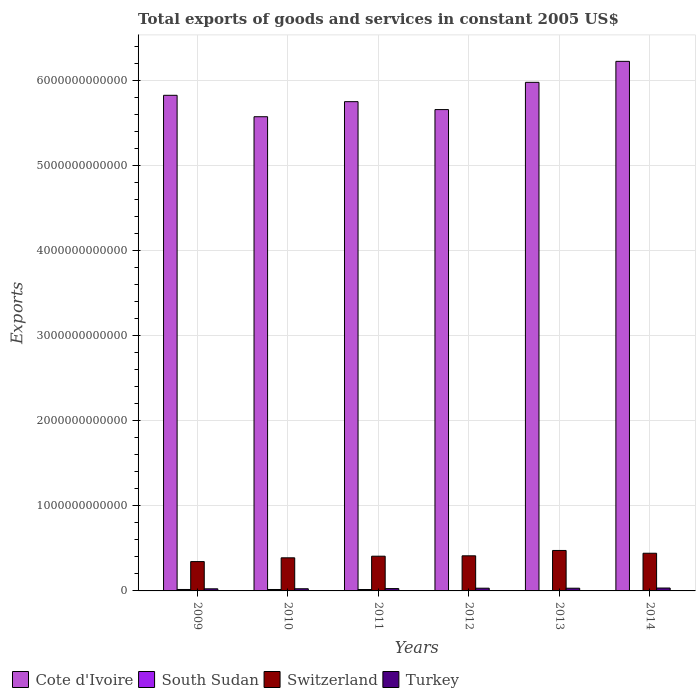How many groups of bars are there?
Offer a very short reply. 6. Are the number of bars per tick equal to the number of legend labels?
Ensure brevity in your answer.  Yes. How many bars are there on the 5th tick from the left?
Your answer should be very brief. 4. How many bars are there on the 2nd tick from the right?
Ensure brevity in your answer.  4. What is the label of the 1st group of bars from the left?
Provide a short and direct response. 2009. What is the total exports of goods and services in Cote d'Ivoire in 2009?
Provide a short and direct response. 5.83e+12. Across all years, what is the maximum total exports of goods and services in South Sudan?
Provide a succinct answer. 1.70e+1. Across all years, what is the minimum total exports of goods and services in Switzerland?
Your response must be concise. 3.45e+11. In which year was the total exports of goods and services in Turkey minimum?
Make the answer very short. 2009. What is the total total exports of goods and services in Switzerland in the graph?
Make the answer very short. 2.48e+12. What is the difference between the total exports of goods and services in Switzerland in 2009 and that in 2012?
Your answer should be compact. -6.78e+1. What is the difference between the total exports of goods and services in Cote d'Ivoire in 2010 and the total exports of goods and services in South Sudan in 2014?
Make the answer very short. 5.57e+12. What is the average total exports of goods and services in Cote d'Ivoire per year?
Ensure brevity in your answer.  5.84e+12. In the year 2012, what is the difference between the total exports of goods and services in Switzerland and total exports of goods and services in South Sudan?
Your response must be concise. 4.12e+11. In how many years, is the total exports of goods and services in South Sudan greater than 1200000000000 US$?
Provide a succinct answer. 0. What is the ratio of the total exports of goods and services in Switzerland in 2011 to that in 2013?
Your answer should be compact. 0.86. Is the total exports of goods and services in Switzerland in 2011 less than that in 2012?
Make the answer very short. Yes. Is the difference between the total exports of goods and services in Switzerland in 2010 and 2012 greater than the difference between the total exports of goods and services in South Sudan in 2010 and 2012?
Your response must be concise. No. What is the difference between the highest and the second highest total exports of goods and services in Turkey?
Offer a very short reply. 2.11e+09. What is the difference between the highest and the lowest total exports of goods and services in Cote d'Ivoire?
Provide a short and direct response. 6.51e+11. In how many years, is the total exports of goods and services in Switzerland greater than the average total exports of goods and services in Switzerland taken over all years?
Give a very brief answer. 3. Is the sum of the total exports of goods and services in Turkey in 2011 and 2014 greater than the maximum total exports of goods and services in Cote d'Ivoire across all years?
Provide a succinct answer. No. Is it the case that in every year, the sum of the total exports of goods and services in Turkey and total exports of goods and services in Cote d'Ivoire is greater than the sum of total exports of goods and services in South Sudan and total exports of goods and services in Switzerland?
Provide a succinct answer. Yes. What does the 4th bar from the left in 2014 represents?
Ensure brevity in your answer.  Turkey. What does the 3rd bar from the right in 2010 represents?
Provide a succinct answer. South Sudan. Are all the bars in the graph horizontal?
Make the answer very short. No. What is the difference between two consecutive major ticks on the Y-axis?
Provide a short and direct response. 1.00e+12. Are the values on the major ticks of Y-axis written in scientific E-notation?
Give a very brief answer. No. Does the graph contain any zero values?
Keep it short and to the point. No. How are the legend labels stacked?
Ensure brevity in your answer.  Horizontal. What is the title of the graph?
Offer a terse response. Total exports of goods and services in constant 2005 US$. What is the label or title of the Y-axis?
Offer a terse response. Exports. What is the Exports of Cote d'Ivoire in 2009?
Make the answer very short. 5.83e+12. What is the Exports of South Sudan in 2009?
Your response must be concise. 1.70e+1. What is the Exports of Switzerland in 2009?
Offer a very short reply. 3.45e+11. What is the Exports in Turkey in 2009?
Your answer should be very brief. 2.47e+1. What is the Exports in Cote d'Ivoire in 2010?
Offer a very short reply. 5.58e+12. What is the Exports of South Sudan in 2010?
Provide a short and direct response. 1.68e+1. What is the Exports of Switzerland in 2010?
Keep it short and to the point. 3.89e+11. What is the Exports in Turkey in 2010?
Provide a succinct answer. 2.55e+1. What is the Exports in Cote d'Ivoire in 2011?
Give a very brief answer. 5.76e+12. What is the Exports in South Sudan in 2011?
Ensure brevity in your answer.  1.64e+1. What is the Exports in Switzerland in 2011?
Your answer should be very brief. 4.09e+11. What is the Exports in Turkey in 2011?
Your response must be concise. 2.75e+1. What is the Exports of Cote d'Ivoire in 2012?
Make the answer very short. 5.66e+12. What is the Exports of South Sudan in 2012?
Your answer should be very brief. 1.33e+09. What is the Exports of Switzerland in 2012?
Provide a succinct answer. 4.13e+11. What is the Exports in Turkey in 2012?
Make the answer very short. 3.20e+1. What is the Exports in Cote d'Ivoire in 2013?
Offer a very short reply. 5.98e+12. What is the Exports in South Sudan in 2013?
Offer a very short reply. 2.66e+09. What is the Exports of Switzerland in 2013?
Keep it short and to the point. 4.76e+11. What is the Exports of Turkey in 2013?
Make the answer very short. 3.19e+1. What is the Exports of Cote d'Ivoire in 2014?
Your answer should be compact. 6.23e+12. What is the Exports in South Sudan in 2014?
Make the answer very short. 4.06e+09. What is the Exports of Switzerland in 2014?
Provide a succinct answer. 4.43e+11. What is the Exports in Turkey in 2014?
Make the answer very short. 3.41e+1. Across all years, what is the maximum Exports of Cote d'Ivoire?
Provide a short and direct response. 6.23e+12. Across all years, what is the maximum Exports in South Sudan?
Give a very brief answer. 1.70e+1. Across all years, what is the maximum Exports in Switzerland?
Make the answer very short. 4.76e+11. Across all years, what is the maximum Exports in Turkey?
Make the answer very short. 3.41e+1. Across all years, what is the minimum Exports of Cote d'Ivoire?
Your response must be concise. 5.58e+12. Across all years, what is the minimum Exports in South Sudan?
Provide a succinct answer. 1.33e+09. Across all years, what is the minimum Exports of Switzerland?
Offer a terse response. 3.45e+11. Across all years, what is the minimum Exports in Turkey?
Provide a short and direct response. 2.47e+1. What is the total Exports in Cote d'Ivoire in the graph?
Keep it short and to the point. 3.50e+13. What is the total Exports of South Sudan in the graph?
Your answer should be very brief. 5.83e+1. What is the total Exports in Switzerland in the graph?
Offer a terse response. 2.48e+12. What is the total Exports of Turkey in the graph?
Your answer should be very brief. 1.76e+11. What is the difference between the Exports of Cote d'Ivoire in 2009 and that in 2010?
Your answer should be compact. 2.52e+11. What is the difference between the Exports in South Sudan in 2009 and that in 2010?
Make the answer very short. 2.67e+08. What is the difference between the Exports of Switzerland in 2009 and that in 2010?
Your response must be concise. -4.43e+1. What is the difference between the Exports of Turkey in 2009 and that in 2010?
Your answer should be very brief. -8.40e+08. What is the difference between the Exports of Cote d'Ivoire in 2009 and that in 2011?
Provide a succinct answer. 7.47e+1. What is the difference between the Exports in South Sudan in 2009 and that in 2011?
Offer a terse response. 6.14e+08. What is the difference between the Exports of Switzerland in 2009 and that in 2011?
Your answer should be very brief. -6.34e+1. What is the difference between the Exports in Turkey in 2009 and that in 2011?
Make the answer very short. -2.85e+09. What is the difference between the Exports in Cote d'Ivoire in 2009 and that in 2012?
Ensure brevity in your answer.  1.68e+11. What is the difference between the Exports of South Sudan in 2009 and that in 2012?
Keep it short and to the point. 1.57e+1. What is the difference between the Exports of Switzerland in 2009 and that in 2012?
Provide a succinct answer. -6.78e+1. What is the difference between the Exports in Turkey in 2009 and that in 2012?
Provide a succinct answer. -7.34e+09. What is the difference between the Exports in Cote d'Ivoire in 2009 and that in 2013?
Your answer should be very brief. -1.53e+11. What is the difference between the Exports of South Sudan in 2009 and that in 2013?
Keep it short and to the point. 1.44e+1. What is the difference between the Exports in Switzerland in 2009 and that in 2013?
Your response must be concise. -1.31e+11. What is the difference between the Exports in Turkey in 2009 and that in 2013?
Make the answer very short. -7.27e+09. What is the difference between the Exports in Cote d'Ivoire in 2009 and that in 2014?
Offer a terse response. -3.99e+11. What is the difference between the Exports in South Sudan in 2009 and that in 2014?
Give a very brief answer. 1.30e+1. What is the difference between the Exports in Switzerland in 2009 and that in 2014?
Offer a terse response. -9.80e+1. What is the difference between the Exports of Turkey in 2009 and that in 2014?
Keep it short and to the point. -9.45e+09. What is the difference between the Exports of Cote d'Ivoire in 2010 and that in 2011?
Offer a very short reply. -1.77e+11. What is the difference between the Exports in South Sudan in 2010 and that in 2011?
Make the answer very short. 3.47e+08. What is the difference between the Exports in Switzerland in 2010 and that in 2011?
Your answer should be compact. -1.91e+1. What is the difference between the Exports of Turkey in 2010 and that in 2011?
Ensure brevity in your answer.  -2.01e+09. What is the difference between the Exports in Cote d'Ivoire in 2010 and that in 2012?
Provide a succinct answer. -8.40e+1. What is the difference between the Exports of South Sudan in 2010 and that in 2012?
Keep it short and to the point. 1.54e+1. What is the difference between the Exports in Switzerland in 2010 and that in 2012?
Your answer should be very brief. -2.35e+1. What is the difference between the Exports of Turkey in 2010 and that in 2012?
Keep it short and to the point. -6.50e+09. What is the difference between the Exports of Cote d'Ivoire in 2010 and that in 2013?
Provide a short and direct response. -4.04e+11. What is the difference between the Exports in South Sudan in 2010 and that in 2013?
Offer a very short reply. 1.41e+1. What is the difference between the Exports in Switzerland in 2010 and that in 2013?
Offer a terse response. -8.64e+1. What is the difference between the Exports of Turkey in 2010 and that in 2013?
Keep it short and to the point. -6.43e+09. What is the difference between the Exports of Cote d'Ivoire in 2010 and that in 2014?
Ensure brevity in your answer.  -6.51e+11. What is the difference between the Exports of South Sudan in 2010 and that in 2014?
Offer a terse response. 1.27e+1. What is the difference between the Exports in Switzerland in 2010 and that in 2014?
Offer a terse response. -5.37e+1. What is the difference between the Exports of Turkey in 2010 and that in 2014?
Your answer should be compact. -8.61e+09. What is the difference between the Exports of Cote d'Ivoire in 2011 and that in 2012?
Offer a terse response. 9.32e+1. What is the difference between the Exports of South Sudan in 2011 and that in 2012?
Make the answer very short. 1.51e+1. What is the difference between the Exports of Switzerland in 2011 and that in 2012?
Offer a terse response. -4.38e+09. What is the difference between the Exports in Turkey in 2011 and that in 2012?
Keep it short and to the point. -4.49e+09. What is the difference between the Exports of Cote d'Ivoire in 2011 and that in 2013?
Make the answer very short. -2.27e+11. What is the difference between the Exports in South Sudan in 2011 and that in 2013?
Provide a succinct answer. 1.38e+1. What is the difference between the Exports of Switzerland in 2011 and that in 2013?
Your answer should be very brief. -6.73e+1. What is the difference between the Exports in Turkey in 2011 and that in 2013?
Keep it short and to the point. -4.42e+09. What is the difference between the Exports of Cote d'Ivoire in 2011 and that in 2014?
Provide a succinct answer. -4.74e+11. What is the difference between the Exports of South Sudan in 2011 and that in 2014?
Give a very brief answer. 1.24e+1. What is the difference between the Exports in Switzerland in 2011 and that in 2014?
Provide a succinct answer. -3.46e+1. What is the difference between the Exports of Turkey in 2011 and that in 2014?
Your answer should be very brief. -6.60e+09. What is the difference between the Exports in Cote d'Ivoire in 2012 and that in 2013?
Keep it short and to the point. -3.20e+11. What is the difference between the Exports of South Sudan in 2012 and that in 2013?
Provide a short and direct response. -1.33e+09. What is the difference between the Exports in Switzerland in 2012 and that in 2013?
Make the answer very short. -6.29e+1. What is the difference between the Exports in Turkey in 2012 and that in 2013?
Your response must be concise. 6.73e+07. What is the difference between the Exports in Cote d'Ivoire in 2012 and that in 2014?
Ensure brevity in your answer.  -5.67e+11. What is the difference between the Exports in South Sudan in 2012 and that in 2014?
Your answer should be very brief. -2.73e+09. What is the difference between the Exports in Switzerland in 2012 and that in 2014?
Your response must be concise. -3.02e+1. What is the difference between the Exports in Turkey in 2012 and that in 2014?
Provide a short and direct response. -2.11e+09. What is the difference between the Exports of Cote d'Ivoire in 2013 and that in 2014?
Provide a short and direct response. -2.47e+11. What is the difference between the Exports of South Sudan in 2013 and that in 2014?
Offer a very short reply. -1.40e+09. What is the difference between the Exports of Switzerland in 2013 and that in 2014?
Your answer should be very brief. 3.27e+1. What is the difference between the Exports in Turkey in 2013 and that in 2014?
Provide a succinct answer. -2.18e+09. What is the difference between the Exports in Cote d'Ivoire in 2009 and the Exports in South Sudan in 2010?
Make the answer very short. 5.81e+12. What is the difference between the Exports of Cote d'Ivoire in 2009 and the Exports of Switzerland in 2010?
Provide a succinct answer. 5.44e+12. What is the difference between the Exports in Cote d'Ivoire in 2009 and the Exports in Turkey in 2010?
Your response must be concise. 5.80e+12. What is the difference between the Exports in South Sudan in 2009 and the Exports in Switzerland in 2010?
Make the answer very short. -3.72e+11. What is the difference between the Exports in South Sudan in 2009 and the Exports in Turkey in 2010?
Your answer should be very brief. -8.46e+09. What is the difference between the Exports of Switzerland in 2009 and the Exports of Turkey in 2010?
Ensure brevity in your answer.  3.20e+11. What is the difference between the Exports of Cote d'Ivoire in 2009 and the Exports of South Sudan in 2011?
Give a very brief answer. 5.81e+12. What is the difference between the Exports in Cote d'Ivoire in 2009 and the Exports in Switzerland in 2011?
Keep it short and to the point. 5.42e+12. What is the difference between the Exports in Cote d'Ivoire in 2009 and the Exports in Turkey in 2011?
Give a very brief answer. 5.80e+12. What is the difference between the Exports of South Sudan in 2009 and the Exports of Switzerland in 2011?
Provide a short and direct response. -3.92e+11. What is the difference between the Exports in South Sudan in 2009 and the Exports in Turkey in 2011?
Offer a very short reply. -1.05e+1. What is the difference between the Exports of Switzerland in 2009 and the Exports of Turkey in 2011?
Your answer should be compact. 3.18e+11. What is the difference between the Exports in Cote d'Ivoire in 2009 and the Exports in South Sudan in 2012?
Your answer should be compact. 5.83e+12. What is the difference between the Exports in Cote d'Ivoire in 2009 and the Exports in Switzerland in 2012?
Give a very brief answer. 5.42e+12. What is the difference between the Exports in Cote d'Ivoire in 2009 and the Exports in Turkey in 2012?
Make the answer very short. 5.80e+12. What is the difference between the Exports of South Sudan in 2009 and the Exports of Switzerland in 2012?
Provide a succinct answer. -3.96e+11. What is the difference between the Exports of South Sudan in 2009 and the Exports of Turkey in 2012?
Your answer should be compact. -1.50e+1. What is the difference between the Exports of Switzerland in 2009 and the Exports of Turkey in 2012?
Provide a short and direct response. 3.13e+11. What is the difference between the Exports of Cote d'Ivoire in 2009 and the Exports of South Sudan in 2013?
Provide a succinct answer. 5.83e+12. What is the difference between the Exports in Cote d'Ivoire in 2009 and the Exports in Switzerland in 2013?
Make the answer very short. 5.35e+12. What is the difference between the Exports of Cote d'Ivoire in 2009 and the Exports of Turkey in 2013?
Keep it short and to the point. 5.80e+12. What is the difference between the Exports of South Sudan in 2009 and the Exports of Switzerland in 2013?
Your response must be concise. -4.59e+11. What is the difference between the Exports in South Sudan in 2009 and the Exports in Turkey in 2013?
Ensure brevity in your answer.  -1.49e+1. What is the difference between the Exports in Switzerland in 2009 and the Exports in Turkey in 2013?
Make the answer very short. 3.13e+11. What is the difference between the Exports of Cote d'Ivoire in 2009 and the Exports of South Sudan in 2014?
Make the answer very short. 5.83e+12. What is the difference between the Exports in Cote d'Ivoire in 2009 and the Exports in Switzerland in 2014?
Give a very brief answer. 5.39e+12. What is the difference between the Exports of Cote d'Ivoire in 2009 and the Exports of Turkey in 2014?
Offer a terse response. 5.80e+12. What is the difference between the Exports in South Sudan in 2009 and the Exports in Switzerland in 2014?
Provide a succinct answer. -4.26e+11. What is the difference between the Exports in South Sudan in 2009 and the Exports in Turkey in 2014?
Give a very brief answer. -1.71e+1. What is the difference between the Exports in Switzerland in 2009 and the Exports in Turkey in 2014?
Provide a succinct answer. 3.11e+11. What is the difference between the Exports in Cote d'Ivoire in 2010 and the Exports in South Sudan in 2011?
Your response must be concise. 5.56e+12. What is the difference between the Exports in Cote d'Ivoire in 2010 and the Exports in Switzerland in 2011?
Offer a terse response. 5.17e+12. What is the difference between the Exports of Cote d'Ivoire in 2010 and the Exports of Turkey in 2011?
Give a very brief answer. 5.55e+12. What is the difference between the Exports of South Sudan in 2010 and the Exports of Switzerland in 2011?
Provide a succinct answer. -3.92e+11. What is the difference between the Exports in South Sudan in 2010 and the Exports in Turkey in 2011?
Provide a short and direct response. -1.07e+1. What is the difference between the Exports of Switzerland in 2010 and the Exports of Turkey in 2011?
Provide a short and direct response. 3.62e+11. What is the difference between the Exports in Cote d'Ivoire in 2010 and the Exports in South Sudan in 2012?
Your answer should be compact. 5.58e+12. What is the difference between the Exports of Cote d'Ivoire in 2010 and the Exports of Switzerland in 2012?
Your answer should be compact. 5.16e+12. What is the difference between the Exports of Cote d'Ivoire in 2010 and the Exports of Turkey in 2012?
Provide a succinct answer. 5.55e+12. What is the difference between the Exports of South Sudan in 2010 and the Exports of Switzerland in 2012?
Make the answer very short. -3.96e+11. What is the difference between the Exports in South Sudan in 2010 and the Exports in Turkey in 2012?
Offer a very short reply. -1.52e+1. What is the difference between the Exports of Switzerland in 2010 and the Exports of Turkey in 2012?
Your answer should be compact. 3.57e+11. What is the difference between the Exports of Cote d'Ivoire in 2010 and the Exports of South Sudan in 2013?
Provide a succinct answer. 5.58e+12. What is the difference between the Exports in Cote d'Ivoire in 2010 and the Exports in Switzerland in 2013?
Offer a very short reply. 5.10e+12. What is the difference between the Exports in Cote d'Ivoire in 2010 and the Exports in Turkey in 2013?
Offer a very short reply. 5.55e+12. What is the difference between the Exports in South Sudan in 2010 and the Exports in Switzerland in 2013?
Offer a terse response. -4.59e+11. What is the difference between the Exports of South Sudan in 2010 and the Exports of Turkey in 2013?
Keep it short and to the point. -1.52e+1. What is the difference between the Exports of Switzerland in 2010 and the Exports of Turkey in 2013?
Your answer should be compact. 3.58e+11. What is the difference between the Exports in Cote d'Ivoire in 2010 and the Exports in South Sudan in 2014?
Offer a very short reply. 5.57e+12. What is the difference between the Exports of Cote d'Ivoire in 2010 and the Exports of Switzerland in 2014?
Provide a succinct answer. 5.13e+12. What is the difference between the Exports of Cote d'Ivoire in 2010 and the Exports of Turkey in 2014?
Provide a succinct answer. 5.54e+12. What is the difference between the Exports of South Sudan in 2010 and the Exports of Switzerland in 2014?
Offer a very short reply. -4.26e+11. What is the difference between the Exports in South Sudan in 2010 and the Exports in Turkey in 2014?
Offer a very short reply. -1.73e+1. What is the difference between the Exports in Switzerland in 2010 and the Exports in Turkey in 2014?
Your response must be concise. 3.55e+11. What is the difference between the Exports of Cote d'Ivoire in 2011 and the Exports of South Sudan in 2012?
Your answer should be very brief. 5.75e+12. What is the difference between the Exports of Cote d'Ivoire in 2011 and the Exports of Switzerland in 2012?
Provide a succinct answer. 5.34e+12. What is the difference between the Exports in Cote d'Ivoire in 2011 and the Exports in Turkey in 2012?
Provide a short and direct response. 5.72e+12. What is the difference between the Exports in South Sudan in 2011 and the Exports in Switzerland in 2012?
Your answer should be compact. -3.97e+11. What is the difference between the Exports of South Sudan in 2011 and the Exports of Turkey in 2012?
Your answer should be compact. -1.56e+1. What is the difference between the Exports in Switzerland in 2011 and the Exports in Turkey in 2012?
Offer a terse response. 3.77e+11. What is the difference between the Exports in Cote d'Ivoire in 2011 and the Exports in South Sudan in 2013?
Provide a succinct answer. 5.75e+12. What is the difference between the Exports of Cote d'Ivoire in 2011 and the Exports of Switzerland in 2013?
Your answer should be very brief. 5.28e+12. What is the difference between the Exports in Cote d'Ivoire in 2011 and the Exports in Turkey in 2013?
Offer a very short reply. 5.72e+12. What is the difference between the Exports of South Sudan in 2011 and the Exports of Switzerland in 2013?
Make the answer very short. -4.59e+11. What is the difference between the Exports of South Sudan in 2011 and the Exports of Turkey in 2013?
Offer a very short reply. -1.55e+1. What is the difference between the Exports of Switzerland in 2011 and the Exports of Turkey in 2013?
Your answer should be very brief. 3.77e+11. What is the difference between the Exports of Cote d'Ivoire in 2011 and the Exports of South Sudan in 2014?
Provide a succinct answer. 5.75e+12. What is the difference between the Exports of Cote d'Ivoire in 2011 and the Exports of Switzerland in 2014?
Provide a succinct answer. 5.31e+12. What is the difference between the Exports in Cote d'Ivoire in 2011 and the Exports in Turkey in 2014?
Provide a succinct answer. 5.72e+12. What is the difference between the Exports of South Sudan in 2011 and the Exports of Switzerland in 2014?
Keep it short and to the point. -4.27e+11. What is the difference between the Exports in South Sudan in 2011 and the Exports in Turkey in 2014?
Your response must be concise. -1.77e+1. What is the difference between the Exports in Switzerland in 2011 and the Exports in Turkey in 2014?
Offer a very short reply. 3.74e+11. What is the difference between the Exports in Cote d'Ivoire in 2012 and the Exports in South Sudan in 2013?
Your answer should be compact. 5.66e+12. What is the difference between the Exports of Cote d'Ivoire in 2012 and the Exports of Switzerland in 2013?
Offer a terse response. 5.19e+12. What is the difference between the Exports in Cote d'Ivoire in 2012 and the Exports in Turkey in 2013?
Provide a short and direct response. 5.63e+12. What is the difference between the Exports of South Sudan in 2012 and the Exports of Switzerland in 2013?
Your answer should be compact. -4.75e+11. What is the difference between the Exports in South Sudan in 2012 and the Exports in Turkey in 2013?
Keep it short and to the point. -3.06e+1. What is the difference between the Exports of Switzerland in 2012 and the Exports of Turkey in 2013?
Provide a short and direct response. 3.81e+11. What is the difference between the Exports of Cote d'Ivoire in 2012 and the Exports of South Sudan in 2014?
Your answer should be very brief. 5.66e+12. What is the difference between the Exports in Cote d'Ivoire in 2012 and the Exports in Switzerland in 2014?
Offer a terse response. 5.22e+12. What is the difference between the Exports in Cote d'Ivoire in 2012 and the Exports in Turkey in 2014?
Make the answer very short. 5.63e+12. What is the difference between the Exports in South Sudan in 2012 and the Exports in Switzerland in 2014?
Keep it short and to the point. -4.42e+11. What is the difference between the Exports in South Sudan in 2012 and the Exports in Turkey in 2014?
Provide a succinct answer. -3.28e+1. What is the difference between the Exports of Switzerland in 2012 and the Exports of Turkey in 2014?
Your response must be concise. 3.79e+11. What is the difference between the Exports of Cote d'Ivoire in 2013 and the Exports of South Sudan in 2014?
Your answer should be compact. 5.98e+12. What is the difference between the Exports of Cote d'Ivoire in 2013 and the Exports of Switzerland in 2014?
Offer a terse response. 5.54e+12. What is the difference between the Exports of Cote d'Ivoire in 2013 and the Exports of Turkey in 2014?
Keep it short and to the point. 5.95e+12. What is the difference between the Exports of South Sudan in 2013 and the Exports of Switzerland in 2014?
Offer a terse response. -4.40e+11. What is the difference between the Exports in South Sudan in 2013 and the Exports in Turkey in 2014?
Your answer should be very brief. -3.15e+1. What is the difference between the Exports of Switzerland in 2013 and the Exports of Turkey in 2014?
Make the answer very short. 4.42e+11. What is the average Exports in Cote d'Ivoire per year?
Ensure brevity in your answer.  5.84e+12. What is the average Exports in South Sudan per year?
Offer a very short reply. 9.72e+09. What is the average Exports of Switzerland per year?
Give a very brief answer. 4.13e+11. What is the average Exports in Turkey per year?
Give a very brief answer. 2.93e+1. In the year 2009, what is the difference between the Exports of Cote d'Ivoire and Exports of South Sudan?
Make the answer very short. 5.81e+12. In the year 2009, what is the difference between the Exports in Cote d'Ivoire and Exports in Switzerland?
Give a very brief answer. 5.48e+12. In the year 2009, what is the difference between the Exports in Cote d'Ivoire and Exports in Turkey?
Ensure brevity in your answer.  5.81e+12. In the year 2009, what is the difference between the Exports in South Sudan and Exports in Switzerland?
Your answer should be compact. -3.28e+11. In the year 2009, what is the difference between the Exports of South Sudan and Exports of Turkey?
Ensure brevity in your answer.  -7.62e+09. In the year 2009, what is the difference between the Exports of Switzerland and Exports of Turkey?
Give a very brief answer. 3.20e+11. In the year 2010, what is the difference between the Exports of Cote d'Ivoire and Exports of South Sudan?
Make the answer very short. 5.56e+12. In the year 2010, what is the difference between the Exports in Cote d'Ivoire and Exports in Switzerland?
Your answer should be compact. 5.19e+12. In the year 2010, what is the difference between the Exports in Cote d'Ivoire and Exports in Turkey?
Your response must be concise. 5.55e+12. In the year 2010, what is the difference between the Exports in South Sudan and Exports in Switzerland?
Offer a terse response. -3.73e+11. In the year 2010, what is the difference between the Exports of South Sudan and Exports of Turkey?
Provide a succinct answer. -8.73e+09. In the year 2010, what is the difference between the Exports in Switzerland and Exports in Turkey?
Make the answer very short. 3.64e+11. In the year 2011, what is the difference between the Exports of Cote d'Ivoire and Exports of South Sudan?
Your answer should be compact. 5.74e+12. In the year 2011, what is the difference between the Exports in Cote d'Ivoire and Exports in Switzerland?
Make the answer very short. 5.35e+12. In the year 2011, what is the difference between the Exports of Cote d'Ivoire and Exports of Turkey?
Your answer should be compact. 5.73e+12. In the year 2011, what is the difference between the Exports of South Sudan and Exports of Switzerland?
Your response must be concise. -3.92e+11. In the year 2011, what is the difference between the Exports in South Sudan and Exports in Turkey?
Provide a succinct answer. -1.11e+1. In the year 2011, what is the difference between the Exports of Switzerland and Exports of Turkey?
Your answer should be very brief. 3.81e+11. In the year 2012, what is the difference between the Exports of Cote d'Ivoire and Exports of South Sudan?
Give a very brief answer. 5.66e+12. In the year 2012, what is the difference between the Exports of Cote d'Ivoire and Exports of Switzerland?
Ensure brevity in your answer.  5.25e+12. In the year 2012, what is the difference between the Exports in Cote d'Ivoire and Exports in Turkey?
Offer a very short reply. 5.63e+12. In the year 2012, what is the difference between the Exports of South Sudan and Exports of Switzerland?
Give a very brief answer. -4.12e+11. In the year 2012, what is the difference between the Exports in South Sudan and Exports in Turkey?
Offer a terse response. -3.07e+1. In the year 2012, what is the difference between the Exports in Switzerland and Exports in Turkey?
Offer a terse response. 3.81e+11. In the year 2013, what is the difference between the Exports in Cote d'Ivoire and Exports in South Sudan?
Offer a very short reply. 5.98e+12. In the year 2013, what is the difference between the Exports in Cote d'Ivoire and Exports in Switzerland?
Provide a succinct answer. 5.51e+12. In the year 2013, what is the difference between the Exports in Cote d'Ivoire and Exports in Turkey?
Make the answer very short. 5.95e+12. In the year 2013, what is the difference between the Exports of South Sudan and Exports of Switzerland?
Your response must be concise. -4.73e+11. In the year 2013, what is the difference between the Exports in South Sudan and Exports in Turkey?
Provide a succinct answer. -2.93e+1. In the year 2013, what is the difference between the Exports of Switzerland and Exports of Turkey?
Ensure brevity in your answer.  4.44e+11. In the year 2014, what is the difference between the Exports of Cote d'Ivoire and Exports of South Sudan?
Keep it short and to the point. 6.23e+12. In the year 2014, what is the difference between the Exports in Cote d'Ivoire and Exports in Switzerland?
Ensure brevity in your answer.  5.79e+12. In the year 2014, what is the difference between the Exports of Cote d'Ivoire and Exports of Turkey?
Your answer should be compact. 6.20e+12. In the year 2014, what is the difference between the Exports of South Sudan and Exports of Switzerland?
Keep it short and to the point. -4.39e+11. In the year 2014, what is the difference between the Exports of South Sudan and Exports of Turkey?
Provide a succinct answer. -3.00e+1. In the year 2014, what is the difference between the Exports of Switzerland and Exports of Turkey?
Keep it short and to the point. 4.09e+11. What is the ratio of the Exports in Cote d'Ivoire in 2009 to that in 2010?
Offer a very short reply. 1.05. What is the ratio of the Exports of South Sudan in 2009 to that in 2010?
Your answer should be very brief. 1.02. What is the ratio of the Exports in Switzerland in 2009 to that in 2010?
Your answer should be compact. 0.89. What is the ratio of the Exports in Turkey in 2009 to that in 2010?
Your response must be concise. 0.97. What is the ratio of the Exports in Cote d'Ivoire in 2009 to that in 2011?
Offer a terse response. 1.01. What is the ratio of the Exports in South Sudan in 2009 to that in 2011?
Make the answer very short. 1.04. What is the ratio of the Exports in Switzerland in 2009 to that in 2011?
Ensure brevity in your answer.  0.84. What is the ratio of the Exports in Turkey in 2009 to that in 2011?
Ensure brevity in your answer.  0.9. What is the ratio of the Exports of Cote d'Ivoire in 2009 to that in 2012?
Keep it short and to the point. 1.03. What is the ratio of the Exports in South Sudan in 2009 to that in 2012?
Your response must be concise. 12.78. What is the ratio of the Exports of Switzerland in 2009 to that in 2012?
Offer a terse response. 0.84. What is the ratio of the Exports of Turkey in 2009 to that in 2012?
Offer a terse response. 0.77. What is the ratio of the Exports of Cote d'Ivoire in 2009 to that in 2013?
Offer a terse response. 0.97. What is the ratio of the Exports in South Sudan in 2009 to that in 2013?
Offer a terse response. 6.41. What is the ratio of the Exports of Switzerland in 2009 to that in 2013?
Offer a very short reply. 0.73. What is the ratio of the Exports of Turkey in 2009 to that in 2013?
Give a very brief answer. 0.77. What is the ratio of the Exports of Cote d'Ivoire in 2009 to that in 2014?
Your response must be concise. 0.94. What is the ratio of the Exports in South Sudan in 2009 to that in 2014?
Offer a very short reply. 4.19. What is the ratio of the Exports in Switzerland in 2009 to that in 2014?
Offer a very short reply. 0.78. What is the ratio of the Exports in Turkey in 2009 to that in 2014?
Ensure brevity in your answer.  0.72. What is the ratio of the Exports of Cote d'Ivoire in 2010 to that in 2011?
Your answer should be very brief. 0.97. What is the ratio of the Exports in South Sudan in 2010 to that in 2011?
Your response must be concise. 1.02. What is the ratio of the Exports of Switzerland in 2010 to that in 2011?
Offer a terse response. 0.95. What is the ratio of the Exports of Turkey in 2010 to that in 2011?
Provide a short and direct response. 0.93. What is the ratio of the Exports in Cote d'Ivoire in 2010 to that in 2012?
Offer a very short reply. 0.99. What is the ratio of the Exports in South Sudan in 2010 to that in 2012?
Your response must be concise. 12.58. What is the ratio of the Exports in Switzerland in 2010 to that in 2012?
Offer a terse response. 0.94. What is the ratio of the Exports of Turkey in 2010 to that in 2012?
Your response must be concise. 0.8. What is the ratio of the Exports in Cote d'Ivoire in 2010 to that in 2013?
Your response must be concise. 0.93. What is the ratio of the Exports in South Sudan in 2010 to that in 2013?
Keep it short and to the point. 6.31. What is the ratio of the Exports of Switzerland in 2010 to that in 2013?
Your answer should be compact. 0.82. What is the ratio of the Exports of Turkey in 2010 to that in 2013?
Give a very brief answer. 0.8. What is the ratio of the Exports of Cote d'Ivoire in 2010 to that in 2014?
Make the answer very short. 0.9. What is the ratio of the Exports in South Sudan in 2010 to that in 2014?
Your answer should be compact. 4.13. What is the ratio of the Exports of Switzerland in 2010 to that in 2014?
Your answer should be very brief. 0.88. What is the ratio of the Exports in Turkey in 2010 to that in 2014?
Provide a succinct answer. 0.75. What is the ratio of the Exports of Cote d'Ivoire in 2011 to that in 2012?
Make the answer very short. 1.02. What is the ratio of the Exports in South Sudan in 2011 to that in 2012?
Your answer should be compact. 12.32. What is the ratio of the Exports in Switzerland in 2011 to that in 2012?
Make the answer very short. 0.99. What is the ratio of the Exports of Turkey in 2011 to that in 2012?
Provide a succinct answer. 0.86. What is the ratio of the Exports in South Sudan in 2011 to that in 2013?
Your response must be concise. 6.18. What is the ratio of the Exports in Switzerland in 2011 to that in 2013?
Provide a short and direct response. 0.86. What is the ratio of the Exports of Turkey in 2011 to that in 2013?
Offer a very short reply. 0.86. What is the ratio of the Exports of Cote d'Ivoire in 2011 to that in 2014?
Your response must be concise. 0.92. What is the ratio of the Exports in South Sudan in 2011 to that in 2014?
Your answer should be very brief. 4.04. What is the ratio of the Exports in Switzerland in 2011 to that in 2014?
Keep it short and to the point. 0.92. What is the ratio of the Exports in Turkey in 2011 to that in 2014?
Offer a very short reply. 0.81. What is the ratio of the Exports of Cote d'Ivoire in 2012 to that in 2013?
Provide a succinct answer. 0.95. What is the ratio of the Exports in South Sudan in 2012 to that in 2013?
Provide a short and direct response. 0.5. What is the ratio of the Exports of Switzerland in 2012 to that in 2013?
Give a very brief answer. 0.87. What is the ratio of the Exports in Turkey in 2012 to that in 2013?
Your answer should be compact. 1. What is the ratio of the Exports of Cote d'Ivoire in 2012 to that in 2014?
Offer a very short reply. 0.91. What is the ratio of the Exports in South Sudan in 2012 to that in 2014?
Provide a short and direct response. 0.33. What is the ratio of the Exports in Switzerland in 2012 to that in 2014?
Give a very brief answer. 0.93. What is the ratio of the Exports of Turkey in 2012 to that in 2014?
Your answer should be compact. 0.94. What is the ratio of the Exports in Cote d'Ivoire in 2013 to that in 2014?
Offer a very short reply. 0.96. What is the ratio of the Exports in South Sudan in 2013 to that in 2014?
Keep it short and to the point. 0.65. What is the ratio of the Exports of Switzerland in 2013 to that in 2014?
Provide a succinct answer. 1.07. What is the ratio of the Exports of Turkey in 2013 to that in 2014?
Ensure brevity in your answer.  0.94. What is the difference between the highest and the second highest Exports in Cote d'Ivoire?
Offer a very short reply. 2.47e+11. What is the difference between the highest and the second highest Exports in South Sudan?
Provide a succinct answer. 2.67e+08. What is the difference between the highest and the second highest Exports in Switzerland?
Give a very brief answer. 3.27e+1. What is the difference between the highest and the second highest Exports of Turkey?
Provide a succinct answer. 2.11e+09. What is the difference between the highest and the lowest Exports in Cote d'Ivoire?
Offer a terse response. 6.51e+11. What is the difference between the highest and the lowest Exports of South Sudan?
Offer a very short reply. 1.57e+1. What is the difference between the highest and the lowest Exports in Switzerland?
Your answer should be very brief. 1.31e+11. What is the difference between the highest and the lowest Exports in Turkey?
Ensure brevity in your answer.  9.45e+09. 